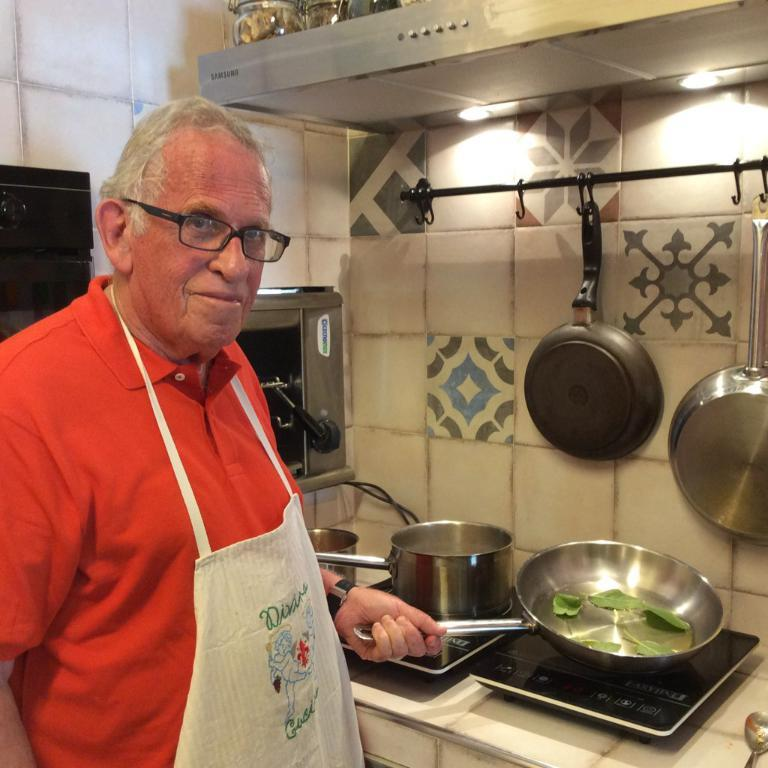What type of flooring is visible in the image? There are tiles in the image. What cooking utensils can be seen in the image? There are bowls and pans visible in the image. What type of stoves are present in the image? There are induction stoves in the image. What is the person in the image wearing? The person in the image is wearing a red color t-shirt. What type of treatment is the hen receiving in the image? There is no hen present in the image, so no treatment can be observed. How does the person in the red t-shirt start the induction stoves in the image? The person in the red t-shirt is not shown starting the induction stoves in the image. 